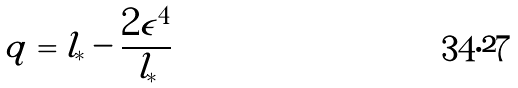Convert formula to latex. <formula><loc_0><loc_0><loc_500><loc_500>q = l _ { * } - \frac { 2 \epsilon ^ { 4 } } { l _ { * } }</formula> 